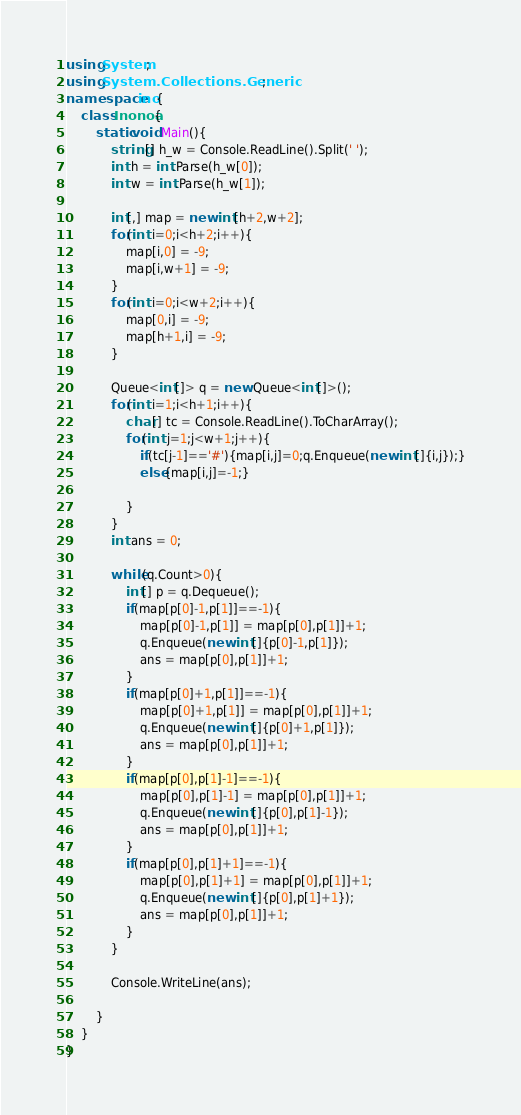<code> <loc_0><loc_0><loc_500><loc_500><_C#_>using System;
using System.Collections.Generic;
namespace ino{
    class Inonoa{
        static void Main(){
            string[] h_w = Console.ReadLine().Split(' ');
            int h = int.Parse(h_w[0]);
            int w = int.Parse(h_w[1]);

            int[,] map = new int[h+2,w+2];
            for(int i=0;i<h+2;i++){
                map[i,0] = -9;
                map[i,w+1] = -9;
            }
            for(int i=0;i<w+2;i++){
                map[0,i] = -9;
                map[h+1,i] = -9;
            }

            Queue<int[]> q = new Queue<int[]>();
            for(int i=1;i<h+1;i++){
                char[] tc = Console.ReadLine().ToCharArray();
                for(int j=1;j<w+1;j++){
                    if(tc[j-1]=='#'){map[i,j]=0;q.Enqueue(new int[]{i,j});}
                    else{map[i,j]=-1;}
                    
                }
            }
            int ans = 0;

            while(q.Count>0){
                int[] p = q.Dequeue();
                if(map[p[0]-1,p[1]]==-1){
                    map[p[0]-1,p[1]] = map[p[0],p[1]]+1;
                    q.Enqueue(new int[]{p[0]-1,p[1]});
                    ans = map[p[0],p[1]]+1;
                }
                if(map[p[0]+1,p[1]]==-1){
                    map[p[0]+1,p[1]] = map[p[0],p[1]]+1;
                    q.Enqueue(new int[]{p[0]+1,p[1]});
                    ans = map[p[0],p[1]]+1;
                }
                if(map[p[0],p[1]-1]==-1){
                    map[p[0],p[1]-1] = map[p[0],p[1]]+1;
                    q.Enqueue(new int[]{p[0],p[1]-1});
                    ans = map[p[0],p[1]]+1;
                }
                if(map[p[0],p[1]+1]==-1){
                    map[p[0],p[1]+1] = map[p[0],p[1]]+1;
                    q.Enqueue(new int[]{p[0],p[1]+1});
                    ans = map[p[0],p[1]]+1;
                }
            }

            Console.WriteLine(ans);

        }
    }
}</code> 